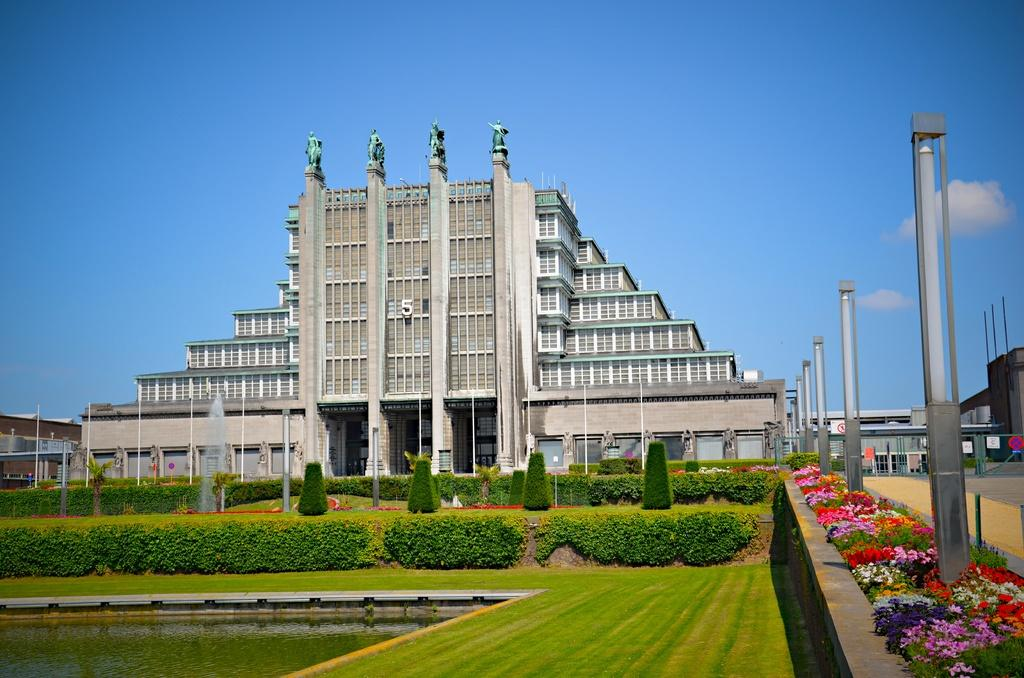What type of structures can be seen in the image? There are buildings in the image. What architectural elements are present in the image? There are walls and poles in the image. What type of vegetation is visible in the image? There are plants, grass, and flowers in the image. What water feature can be seen in the image? There is a water fountain in the image. What other objects are present in the image? There are boards and other objects in the image. What can be seen in the background of the image? The sky is visible in the background of the image. What flavor of fear can be tasted in the image? There is no fear present in the image, and therefore no flavor can be associated with it. How many sneezes can be heard in the image? There are no sounds, including sneezes, present in the image. 